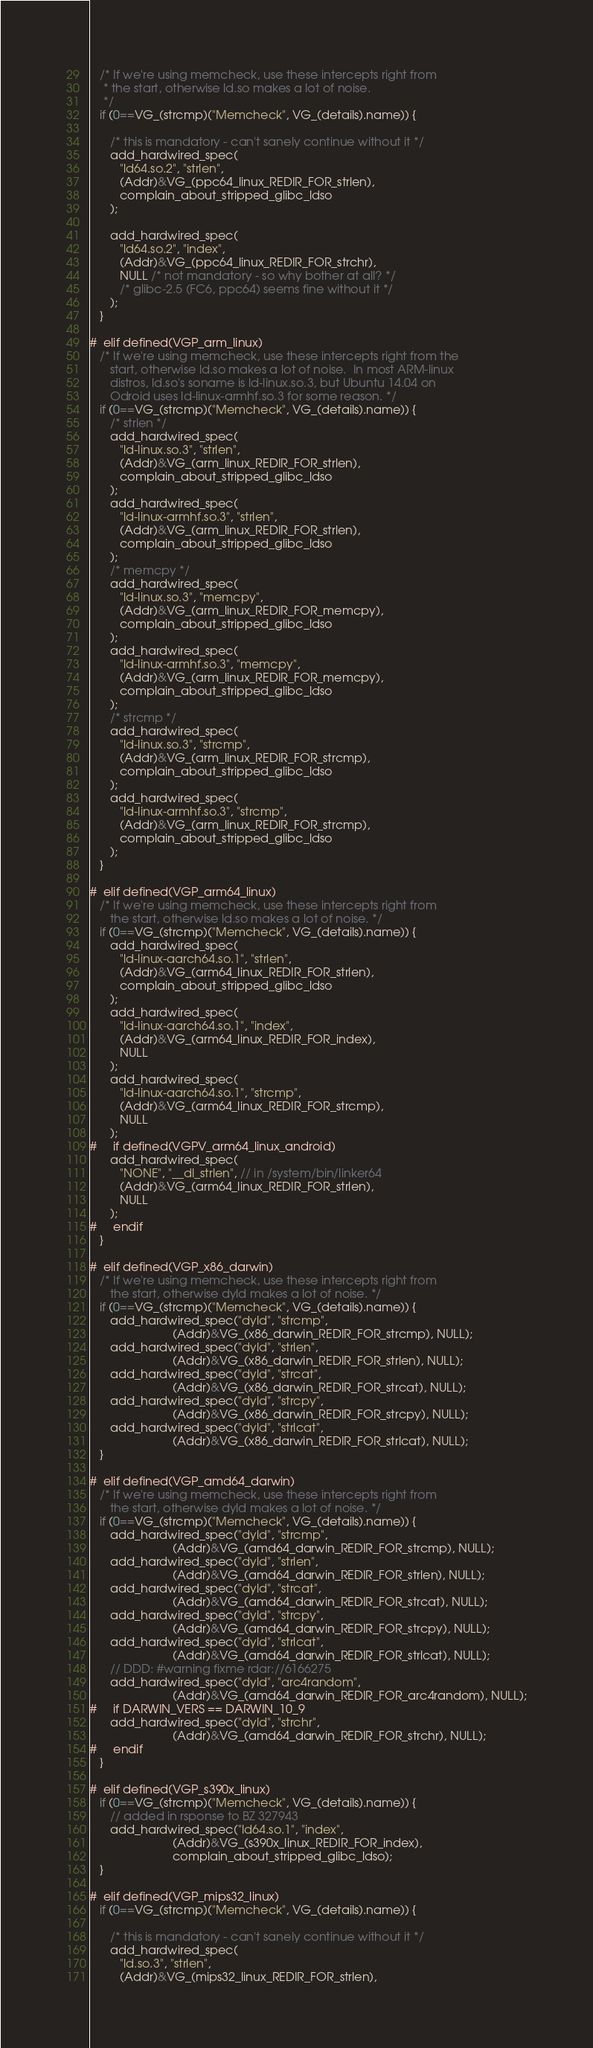<code> <loc_0><loc_0><loc_500><loc_500><_C_>   /* If we're using memcheck, use these intercepts right from
    * the start, otherwise ld.so makes a lot of noise.
    */
   if (0==VG_(strcmp)("Memcheck", VG_(details).name)) {

      /* this is mandatory - can't sanely continue without it */
      add_hardwired_spec(
         "ld64.so.2", "strlen",
         (Addr)&VG_(ppc64_linux_REDIR_FOR_strlen),
         complain_about_stripped_glibc_ldso
      );

      add_hardwired_spec(
         "ld64.so.2", "index",
         (Addr)&VG_(ppc64_linux_REDIR_FOR_strchr),
         NULL /* not mandatory - so why bother at all? */
         /* glibc-2.5 (FC6, ppc64) seems fine without it */
      );
   }

#  elif defined(VGP_arm_linux)
   /* If we're using memcheck, use these intercepts right from the
      start, otherwise ld.so makes a lot of noise.  In most ARM-linux
      distros, ld.so's soname is ld-linux.so.3, but Ubuntu 14.04 on
      Odroid uses ld-linux-armhf.so.3 for some reason. */
   if (0==VG_(strcmp)("Memcheck", VG_(details).name)) {
      /* strlen */
      add_hardwired_spec(
         "ld-linux.so.3", "strlen",
         (Addr)&VG_(arm_linux_REDIR_FOR_strlen),
         complain_about_stripped_glibc_ldso
      );
      add_hardwired_spec(
         "ld-linux-armhf.so.3", "strlen",
         (Addr)&VG_(arm_linux_REDIR_FOR_strlen),
         complain_about_stripped_glibc_ldso
      );
      /* memcpy */
      add_hardwired_spec(
         "ld-linux.so.3", "memcpy",
         (Addr)&VG_(arm_linux_REDIR_FOR_memcpy),
         complain_about_stripped_glibc_ldso
      );
      add_hardwired_spec(
         "ld-linux-armhf.so.3", "memcpy",
         (Addr)&VG_(arm_linux_REDIR_FOR_memcpy),
         complain_about_stripped_glibc_ldso
      );
      /* strcmp */
      add_hardwired_spec(
         "ld-linux.so.3", "strcmp",
         (Addr)&VG_(arm_linux_REDIR_FOR_strcmp),
         complain_about_stripped_glibc_ldso
      );
      add_hardwired_spec(
         "ld-linux-armhf.so.3", "strcmp",
         (Addr)&VG_(arm_linux_REDIR_FOR_strcmp),
         complain_about_stripped_glibc_ldso
      );
   }

#  elif defined(VGP_arm64_linux)
   /* If we're using memcheck, use these intercepts right from
      the start, otherwise ld.so makes a lot of noise. */
   if (0==VG_(strcmp)("Memcheck", VG_(details).name)) {
      add_hardwired_spec(
         "ld-linux-aarch64.so.1", "strlen",
         (Addr)&VG_(arm64_linux_REDIR_FOR_strlen),
         complain_about_stripped_glibc_ldso
      );
      add_hardwired_spec(
         "ld-linux-aarch64.so.1", "index",
         (Addr)&VG_(arm64_linux_REDIR_FOR_index),
         NULL 
      );
      add_hardwired_spec(
         "ld-linux-aarch64.so.1", "strcmp",
         (Addr)&VG_(arm64_linux_REDIR_FOR_strcmp),
         NULL 
      );
#     if defined(VGPV_arm64_linux_android)
      add_hardwired_spec(
         "NONE", "__dl_strlen", // in /system/bin/linker64
         (Addr)&VG_(arm64_linux_REDIR_FOR_strlen),
         NULL
      );
#     endif
   }

#  elif defined(VGP_x86_darwin)
   /* If we're using memcheck, use these intercepts right from
      the start, otherwise dyld makes a lot of noise. */
   if (0==VG_(strcmp)("Memcheck", VG_(details).name)) {
      add_hardwired_spec("dyld", "strcmp",
                         (Addr)&VG_(x86_darwin_REDIR_FOR_strcmp), NULL);
      add_hardwired_spec("dyld", "strlen",
                         (Addr)&VG_(x86_darwin_REDIR_FOR_strlen), NULL);
      add_hardwired_spec("dyld", "strcat",
                         (Addr)&VG_(x86_darwin_REDIR_FOR_strcat), NULL);
      add_hardwired_spec("dyld", "strcpy",
                         (Addr)&VG_(x86_darwin_REDIR_FOR_strcpy), NULL);
      add_hardwired_spec("dyld", "strlcat",
                         (Addr)&VG_(x86_darwin_REDIR_FOR_strlcat), NULL);
   }

#  elif defined(VGP_amd64_darwin)
   /* If we're using memcheck, use these intercepts right from
      the start, otherwise dyld makes a lot of noise. */
   if (0==VG_(strcmp)("Memcheck", VG_(details).name)) {
      add_hardwired_spec("dyld", "strcmp",
                         (Addr)&VG_(amd64_darwin_REDIR_FOR_strcmp), NULL);
      add_hardwired_spec("dyld", "strlen",
                         (Addr)&VG_(amd64_darwin_REDIR_FOR_strlen), NULL);
      add_hardwired_spec("dyld", "strcat",
                         (Addr)&VG_(amd64_darwin_REDIR_FOR_strcat), NULL);
      add_hardwired_spec("dyld", "strcpy",
                         (Addr)&VG_(amd64_darwin_REDIR_FOR_strcpy), NULL);
      add_hardwired_spec("dyld", "strlcat",
                         (Addr)&VG_(amd64_darwin_REDIR_FOR_strlcat), NULL);
      // DDD: #warning fixme rdar://6166275
      add_hardwired_spec("dyld", "arc4random",
                         (Addr)&VG_(amd64_darwin_REDIR_FOR_arc4random), NULL);
#     if DARWIN_VERS == DARWIN_10_9
      add_hardwired_spec("dyld", "strchr",
                         (Addr)&VG_(amd64_darwin_REDIR_FOR_strchr), NULL);
#     endif
   }

#  elif defined(VGP_s390x_linux)
   if (0==VG_(strcmp)("Memcheck", VG_(details).name)) {
      // added in rsponse to BZ 327943
      add_hardwired_spec("ld64.so.1", "index",
                         (Addr)&VG_(s390x_linux_REDIR_FOR_index),
                         complain_about_stripped_glibc_ldso);
   }

#  elif defined(VGP_mips32_linux)
   if (0==VG_(strcmp)("Memcheck", VG_(details).name)) {

      /* this is mandatory - can't sanely continue without it */
      add_hardwired_spec(
         "ld.so.3", "strlen",
         (Addr)&VG_(mips32_linux_REDIR_FOR_strlen),</code> 